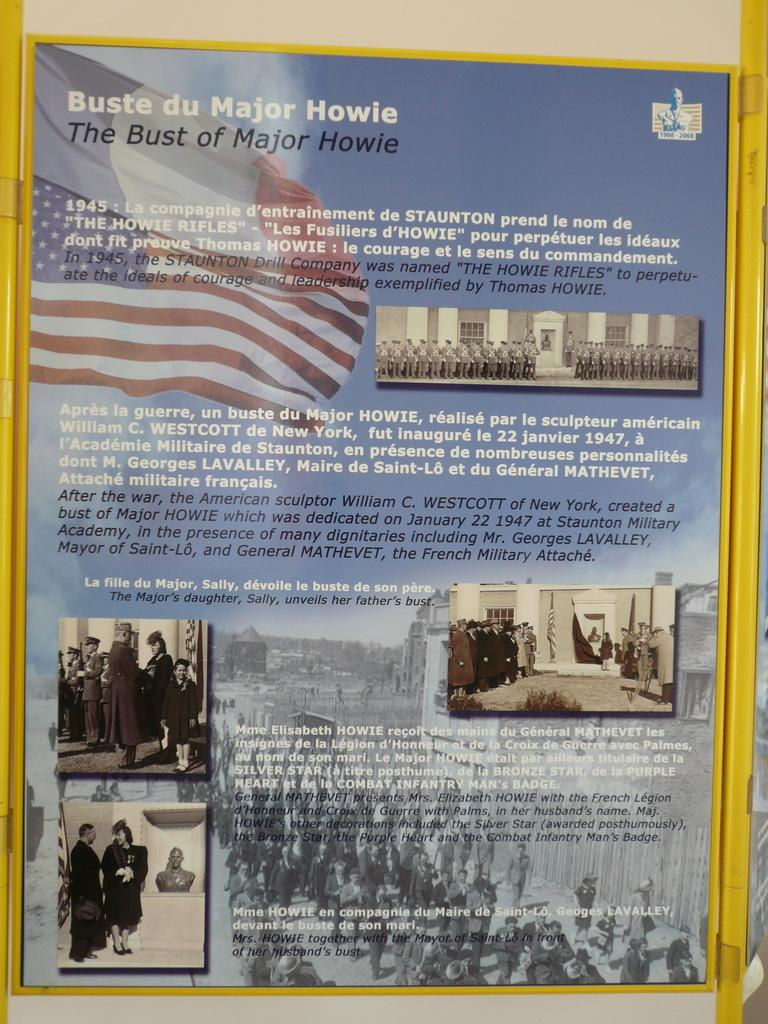What is the main object in the image? There is a poster in the image. What is featured on the poster? The poster contains a flag and persons. Is there any text on the poster? Yes, there is text on the poster. What time of day is depicted in the image? The time of day is not depicted in the image, as it only shows a poster with a flag, persons, and text. 